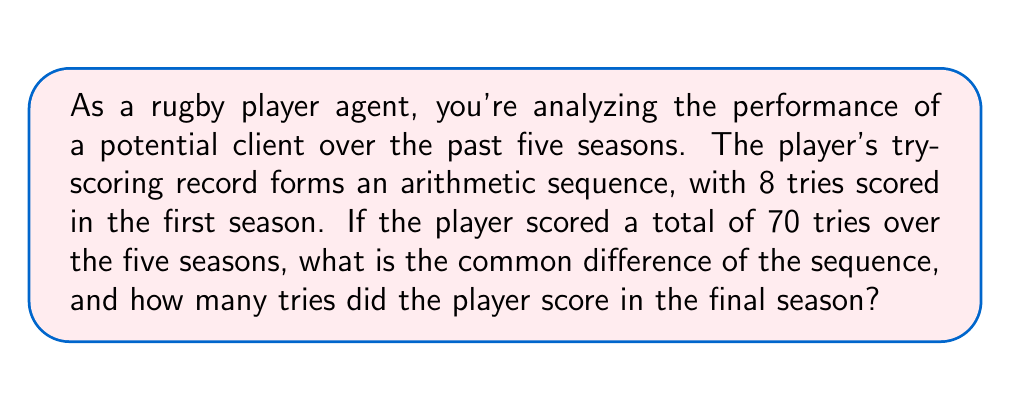Could you help me with this problem? Let's approach this step-by-step:

1) Let $a$ be the first term (8 tries) and $d$ be the common difference.

2) The sequence of tries scored over 5 seasons would be:
   $a, a+d, a+2d, a+3d, a+4d$

3) We know that the sum of these 5 terms is 70. We can use the arithmetic sequence sum formula:

   $$S_n = \frac{n}{2}(a_1 + a_n)$$

   Where $S_n$ is the sum, $n$ is the number of terms, $a_1$ is the first term, and $a_n$ is the last term.

4) Substituting our known values:

   $$70 = \frac{5}{2}(8 + (8+4d))$$

5) Simplify:
   
   $$70 = \frac{5}{2}(16+4d)$$
   $$70 = 40 + 10d$$

6) Solve for $d$:
   
   $$30 = 10d$$
   $$d = 3$$

7) Now that we know $d$, we can find the number of tries in the final season:
   
   Final season tries $= a + 4d = 8 + 4(3) = 20$
Answer: The common difference of the sequence is 3, and the player scored 20 tries in the final season. 